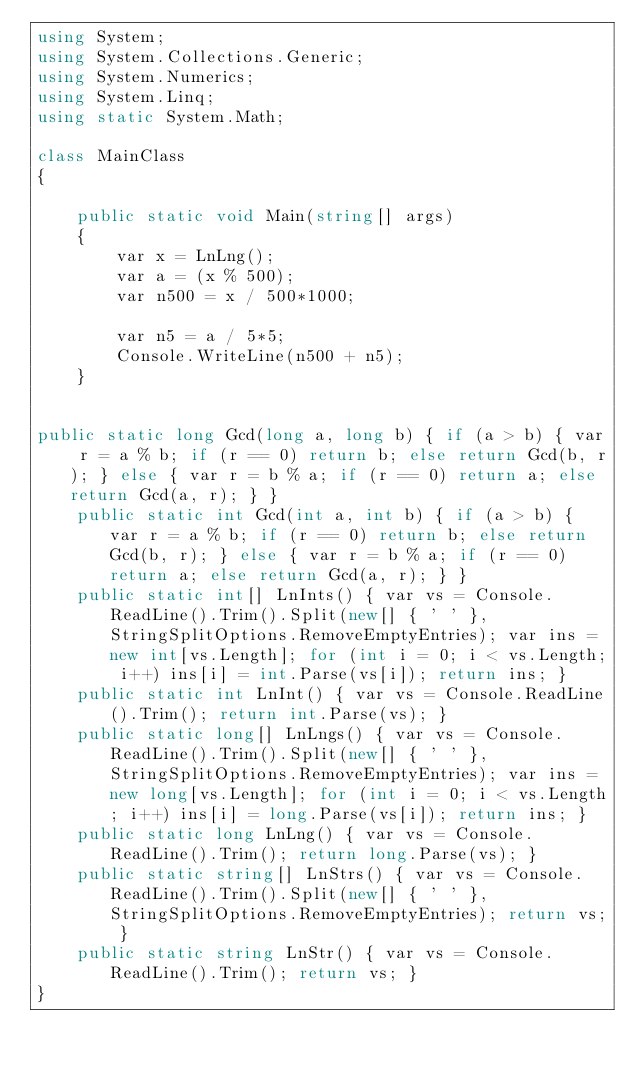Convert code to text. <code><loc_0><loc_0><loc_500><loc_500><_C#_>using System;
using System.Collections.Generic;
using System.Numerics;
using System.Linq;
using static System.Math;

class MainClass
{

    public static void Main(string[] args)
    {
        var x = LnLng();
        var a = (x % 500);
        var n500 = x / 500*1000;
        
        var n5 = a / 5*5;
        Console.WriteLine(n500 + n5);
    }
   

public static long Gcd(long a, long b) { if (a > b) { var r = a % b; if (r == 0) return b; else return Gcd(b, r); } else { var r = b % a; if (r == 0) return a; else return Gcd(a, r); } }
    public static int Gcd(int a, int b) { if (a > b) { var r = a % b; if (r == 0) return b; else return Gcd(b, r); } else { var r = b % a; if (r == 0) return a; else return Gcd(a, r); } }
    public static int[] LnInts() { var vs = Console.ReadLine().Trim().Split(new[] { ' ' }, StringSplitOptions.RemoveEmptyEntries); var ins = new int[vs.Length]; for (int i = 0; i < vs.Length; i++) ins[i] = int.Parse(vs[i]); return ins; }
    public static int LnInt() { var vs = Console.ReadLine().Trim(); return int.Parse(vs); }
    public static long[] LnLngs() { var vs = Console.ReadLine().Trim().Split(new[] { ' ' }, StringSplitOptions.RemoveEmptyEntries); var ins = new long[vs.Length]; for (int i = 0; i < vs.Length; i++) ins[i] = long.Parse(vs[i]); return ins; }
    public static long LnLng() { var vs = Console.ReadLine().Trim(); return long.Parse(vs); }
    public static string[] LnStrs() { var vs = Console.ReadLine().Trim().Split(new[] { ' ' }, StringSplitOptions.RemoveEmptyEntries); return vs; }
    public static string LnStr() { var vs = Console.ReadLine().Trim(); return vs; }
}

</code> 